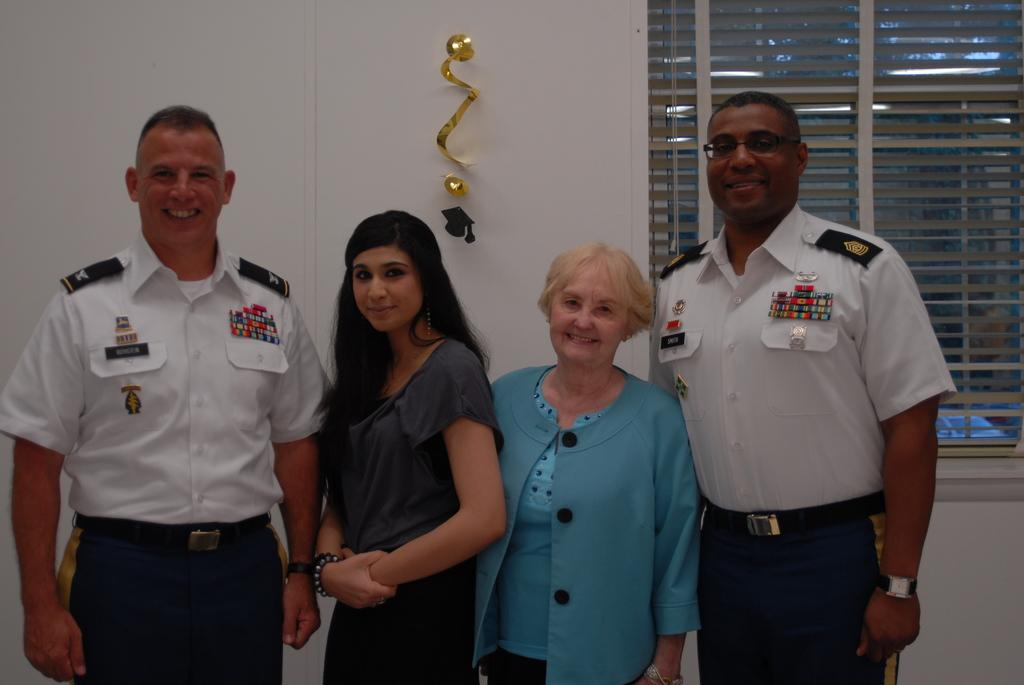What can be seen in the image? There are people standing in the image. Where are the people standing? The people are standing on the floor. What can be seen in the background of the image? There are hooks and blinds in the background of the image. What type of crime is being committed by the queen in the image? There is no queen or crime present in the image. How many stamps are visible on the people in the image? There are no stamps visible on the people in the image. 